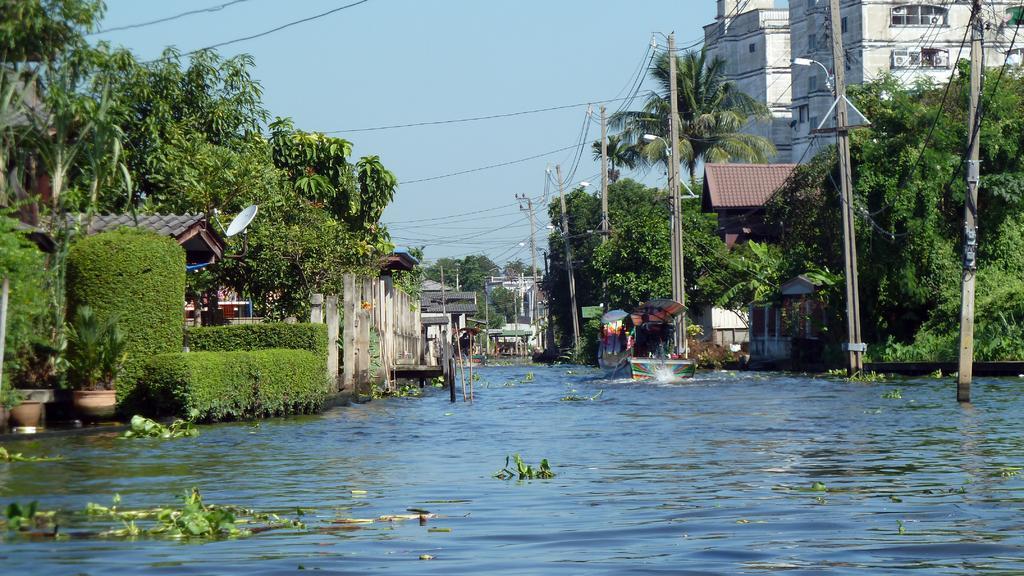Could you give a brief overview of what you see in this image? This image consists of water. On the left and right, there are buildings along with the trees and poles. At the top, there is a sky. And we can see a boat in the water. On the left, there are potted plants. And we can see a boat in the water. 